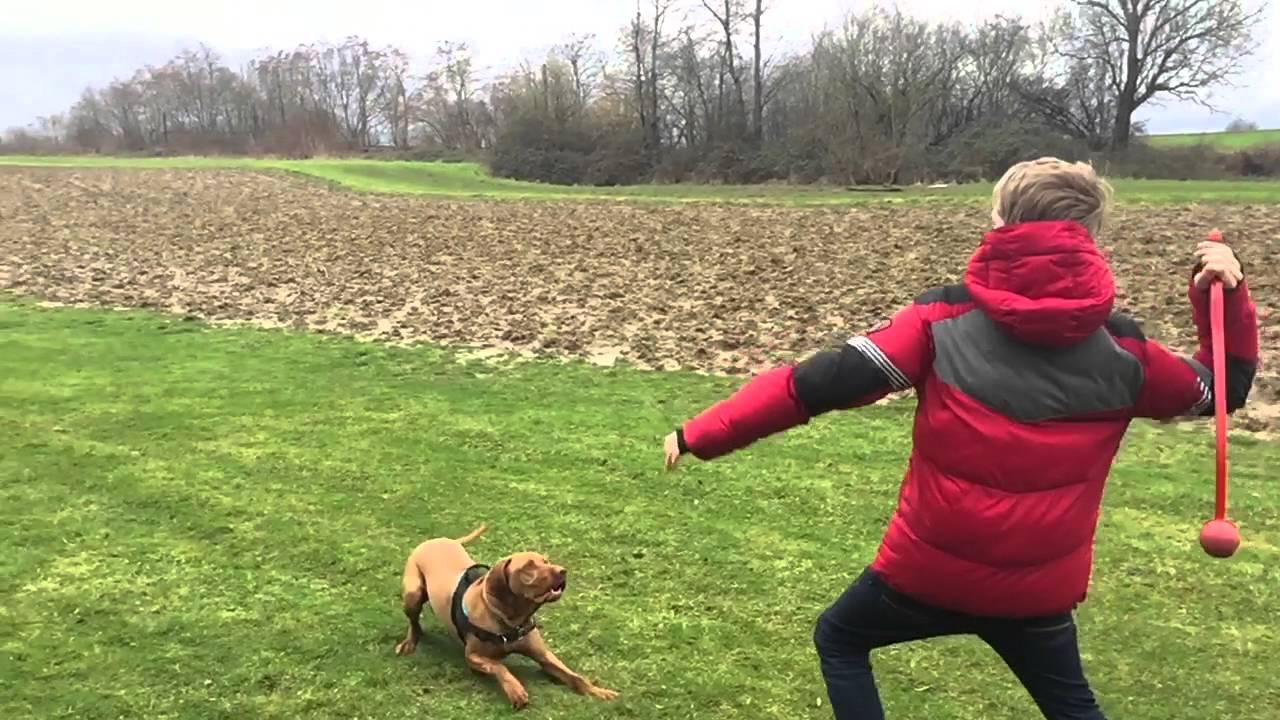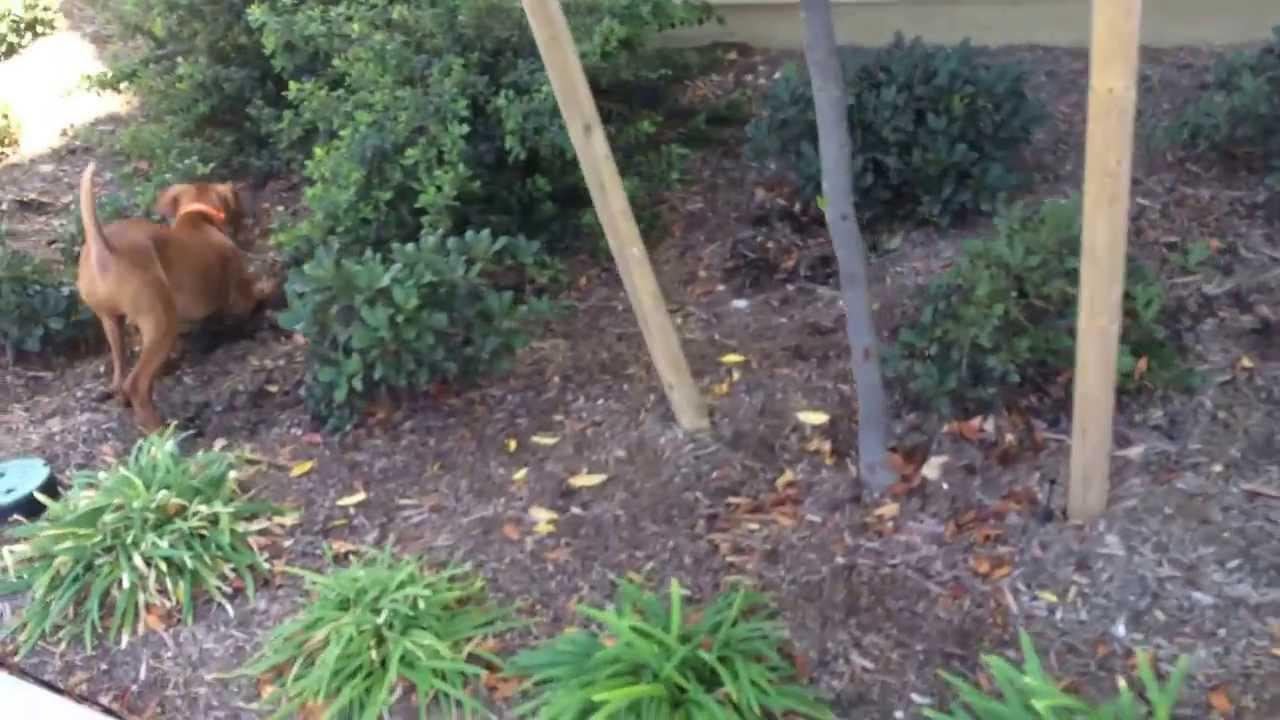The first image is the image on the left, the second image is the image on the right. Given the left and right images, does the statement "There's at least one dog on a leash in one picture and the other picture of a dog is taken at the beach." hold true? Answer yes or no. No. The first image is the image on the left, the second image is the image on the right. Assess this claim about the two images: "A female is standing behind a dog with its head and body turned leftward in the right image.". Correct or not? Answer yes or no. No. 